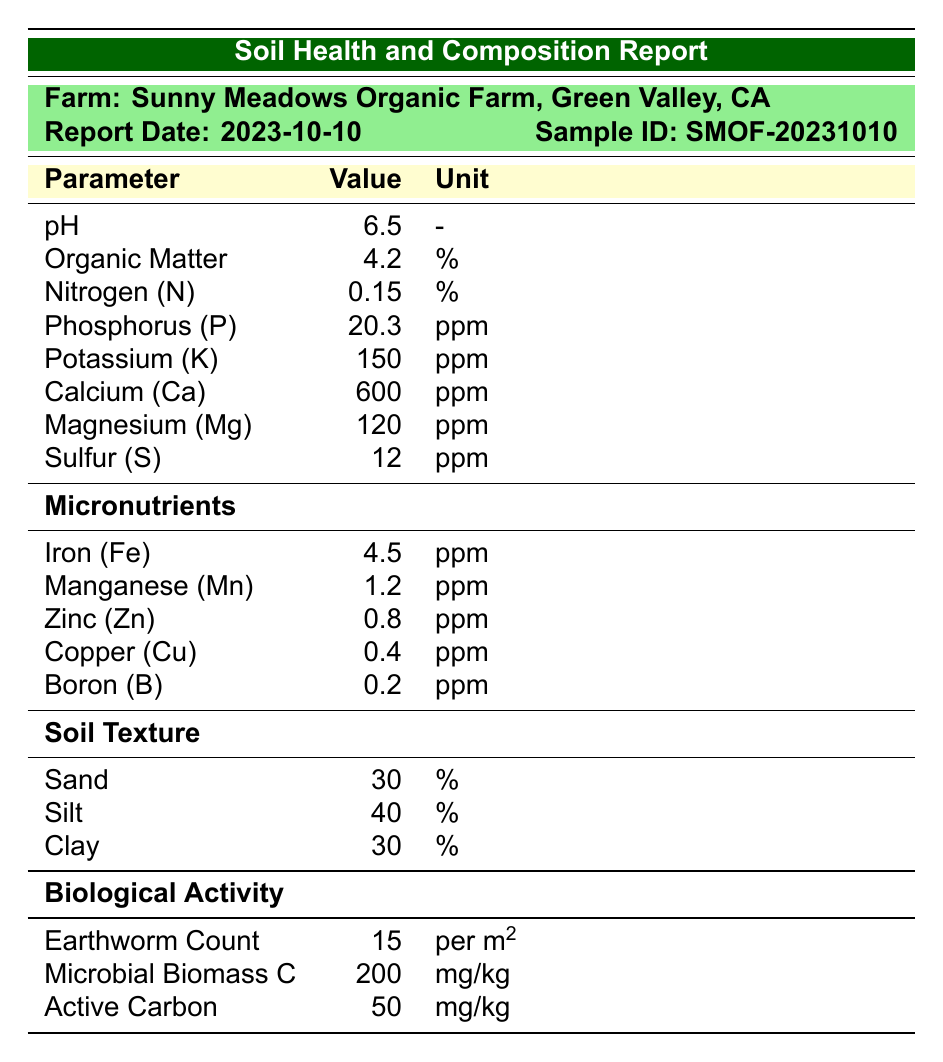What is the pH level of the soil? The pH level is directly provided in the table under the "Parameter" column, showing a value of 6.5 for pH.
Answer: 6.5 What percentage of organic matter is found in the soil? The organic matter percentage is displayed in the table under the "Parameter" column, where it shows a value of 4.2%.
Answer: 4.2% Is the earthworm count per square meter over 10? The earthworm count is listed as 15 per square meter, which is indeed greater than 10.
Answer: Yes What is the total amount of potassium and calcium in ppm? The table lists potassium at 150 ppm and calcium at 600 ppm. Adding these together gives 150 + 600 = 750 ppm.
Answer: 750 ppm What actions are recommended to improve nitrogen levels? The recommendations indicate to "Apply organic compost to enhance nitrogen content." This can be found in the 'Recommendations' section of the report.
Answer: Apply organic compost What is the average percentage of sand, silt, and clay in the soil? The table shows 30% sand, 40% silt, and 30% clay. The total percentage is 30 + 40 + 30 = 100%. To find the average, divide by 3: 100% / 3 = 33.33%.
Answer: 33.33% Is the level of manganese within the typical range of 0.5-2.5 ppm? The manganese level listed is 1.2 ppm, which is within the specified range of 0.5-2.5 ppm.
Answer: Yes What might be a necessary amendment to maintain optimal pH? The recommendations specify using lime amendments to maintain optimal pH, which can be found in the 'Recommendations' section of the report.
Answer: Use lime amendments What is the difference between the levels of phosphorus and nitrogen in the soil? The phosphorus level is 20.3 ppm, and nitrogen is 0.15%. To find the difference we first need both in the same unit; convert nitrogen to ppm: 0.15% is equal to 1500 ppm. The difference is 1500 - 20.3 = 1479.7 ppm.
Answer: 1479.7 ppm 